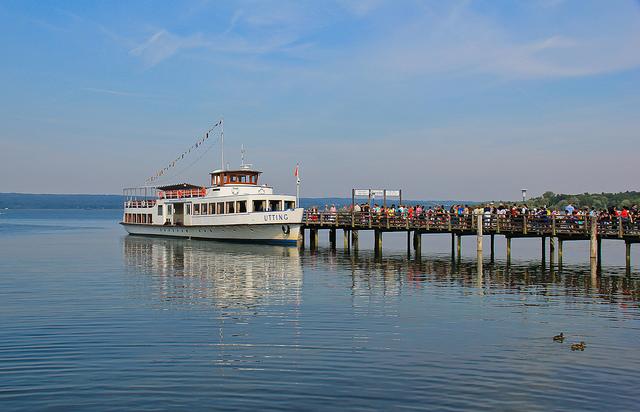What city is on the side of the boat?
Short answer required. Cutting. Which of these boats appears ready to be used on a fishing trip?
Quick response, please. None. Is the boat next to a pier?
Keep it brief. Yes. Is it a hazy day?
Write a very short answer. No. Are the people going on a cruise?
Keep it brief. No. Are there more than one boats in this scene?
Keep it brief. No. How many birds are in the picture?
Quick response, please. 2. How many boats are there?
Concise answer only. 1. How many boats can you count?
Write a very short answer. 1. What letter does the dock seem to make?
Write a very short answer. I. What is in the water?
Short answer required. Boat. 